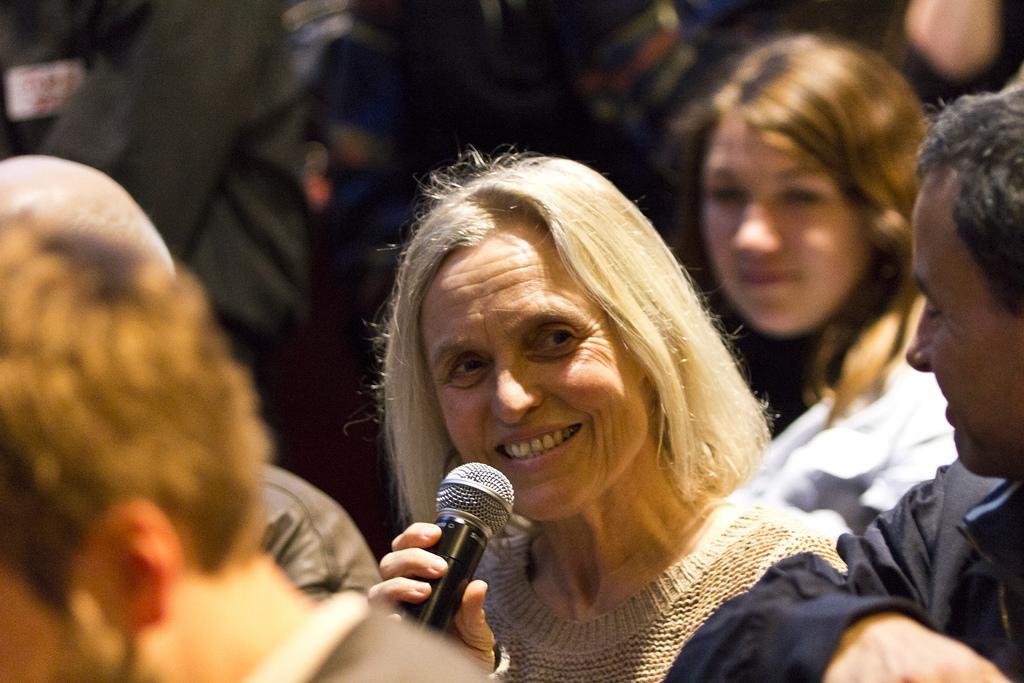Can you describe this image briefly? In this image, we can see few peoples are smiling. And the middle of the image, The woman is holding a microphone. And she is smiling. 